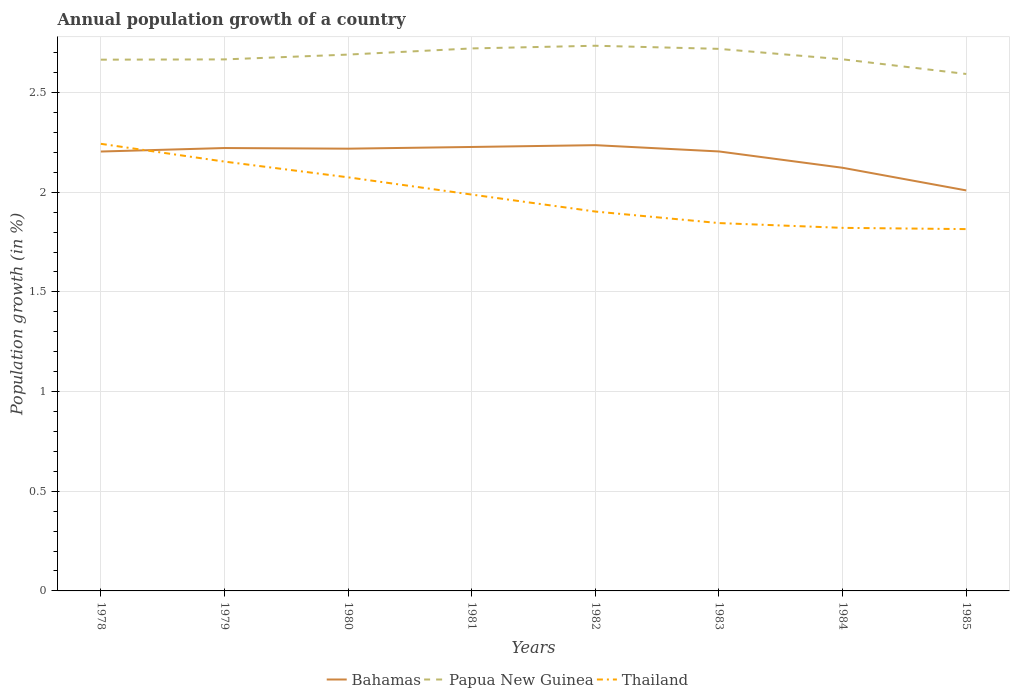How many different coloured lines are there?
Your response must be concise. 3. Does the line corresponding to Bahamas intersect with the line corresponding to Papua New Guinea?
Your response must be concise. No. Is the number of lines equal to the number of legend labels?
Give a very brief answer. Yes. Across all years, what is the maximum annual population growth in Papua New Guinea?
Offer a terse response. 2.59. What is the total annual population growth in Papua New Guinea in the graph?
Your answer should be very brief. -0.06. What is the difference between the highest and the second highest annual population growth in Papua New Guinea?
Provide a succinct answer. 0.14. Is the annual population growth in Papua New Guinea strictly greater than the annual population growth in Bahamas over the years?
Make the answer very short. No. How many lines are there?
Provide a short and direct response. 3. What is the difference between two consecutive major ticks on the Y-axis?
Ensure brevity in your answer.  0.5. Are the values on the major ticks of Y-axis written in scientific E-notation?
Offer a very short reply. No. Where does the legend appear in the graph?
Give a very brief answer. Bottom center. How many legend labels are there?
Give a very brief answer. 3. What is the title of the graph?
Make the answer very short. Annual population growth of a country. What is the label or title of the Y-axis?
Provide a short and direct response. Population growth (in %). What is the Population growth (in %) in Bahamas in 1978?
Ensure brevity in your answer.  2.2. What is the Population growth (in %) of Papua New Guinea in 1978?
Your answer should be very brief. 2.66. What is the Population growth (in %) of Thailand in 1978?
Ensure brevity in your answer.  2.24. What is the Population growth (in %) of Bahamas in 1979?
Give a very brief answer. 2.22. What is the Population growth (in %) in Papua New Guinea in 1979?
Give a very brief answer. 2.67. What is the Population growth (in %) of Thailand in 1979?
Your answer should be very brief. 2.15. What is the Population growth (in %) in Bahamas in 1980?
Make the answer very short. 2.22. What is the Population growth (in %) of Papua New Guinea in 1980?
Offer a terse response. 2.69. What is the Population growth (in %) of Thailand in 1980?
Your response must be concise. 2.07. What is the Population growth (in %) of Bahamas in 1981?
Keep it short and to the point. 2.23. What is the Population growth (in %) in Papua New Guinea in 1981?
Your response must be concise. 2.72. What is the Population growth (in %) of Thailand in 1981?
Keep it short and to the point. 1.99. What is the Population growth (in %) in Bahamas in 1982?
Offer a terse response. 2.24. What is the Population growth (in %) in Papua New Guinea in 1982?
Provide a succinct answer. 2.73. What is the Population growth (in %) of Thailand in 1982?
Ensure brevity in your answer.  1.9. What is the Population growth (in %) of Bahamas in 1983?
Your response must be concise. 2.2. What is the Population growth (in %) of Papua New Guinea in 1983?
Give a very brief answer. 2.72. What is the Population growth (in %) of Thailand in 1983?
Offer a very short reply. 1.85. What is the Population growth (in %) in Bahamas in 1984?
Offer a very short reply. 2.12. What is the Population growth (in %) in Papua New Guinea in 1984?
Provide a succinct answer. 2.67. What is the Population growth (in %) of Thailand in 1984?
Your answer should be very brief. 1.82. What is the Population growth (in %) of Bahamas in 1985?
Offer a very short reply. 2.01. What is the Population growth (in %) of Papua New Guinea in 1985?
Make the answer very short. 2.59. What is the Population growth (in %) in Thailand in 1985?
Provide a succinct answer. 1.81. Across all years, what is the maximum Population growth (in %) of Bahamas?
Offer a terse response. 2.24. Across all years, what is the maximum Population growth (in %) in Papua New Guinea?
Keep it short and to the point. 2.73. Across all years, what is the maximum Population growth (in %) of Thailand?
Provide a succinct answer. 2.24. Across all years, what is the minimum Population growth (in %) of Bahamas?
Make the answer very short. 2.01. Across all years, what is the minimum Population growth (in %) of Papua New Guinea?
Offer a very short reply. 2.59. Across all years, what is the minimum Population growth (in %) of Thailand?
Offer a terse response. 1.81. What is the total Population growth (in %) in Bahamas in the graph?
Make the answer very short. 17.44. What is the total Population growth (in %) of Papua New Guinea in the graph?
Offer a terse response. 21.46. What is the total Population growth (in %) of Thailand in the graph?
Your response must be concise. 15.84. What is the difference between the Population growth (in %) of Bahamas in 1978 and that in 1979?
Ensure brevity in your answer.  -0.02. What is the difference between the Population growth (in %) of Papua New Guinea in 1978 and that in 1979?
Your answer should be compact. -0. What is the difference between the Population growth (in %) in Thailand in 1978 and that in 1979?
Your response must be concise. 0.09. What is the difference between the Population growth (in %) in Bahamas in 1978 and that in 1980?
Provide a succinct answer. -0.01. What is the difference between the Population growth (in %) in Papua New Guinea in 1978 and that in 1980?
Ensure brevity in your answer.  -0.03. What is the difference between the Population growth (in %) of Thailand in 1978 and that in 1980?
Your response must be concise. 0.17. What is the difference between the Population growth (in %) in Bahamas in 1978 and that in 1981?
Provide a short and direct response. -0.02. What is the difference between the Population growth (in %) in Papua New Guinea in 1978 and that in 1981?
Your answer should be very brief. -0.06. What is the difference between the Population growth (in %) in Thailand in 1978 and that in 1981?
Make the answer very short. 0.25. What is the difference between the Population growth (in %) in Bahamas in 1978 and that in 1982?
Offer a very short reply. -0.03. What is the difference between the Population growth (in %) in Papua New Guinea in 1978 and that in 1982?
Offer a terse response. -0.07. What is the difference between the Population growth (in %) in Thailand in 1978 and that in 1982?
Offer a terse response. 0.34. What is the difference between the Population growth (in %) in Bahamas in 1978 and that in 1983?
Provide a succinct answer. -0. What is the difference between the Population growth (in %) of Papua New Guinea in 1978 and that in 1983?
Your answer should be very brief. -0.05. What is the difference between the Population growth (in %) in Thailand in 1978 and that in 1983?
Your answer should be compact. 0.4. What is the difference between the Population growth (in %) in Bahamas in 1978 and that in 1984?
Your answer should be very brief. 0.08. What is the difference between the Population growth (in %) of Papua New Guinea in 1978 and that in 1984?
Provide a succinct answer. -0. What is the difference between the Population growth (in %) of Thailand in 1978 and that in 1984?
Your answer should be very brief. 0.42. What is the difference between the Population growth (in %) in Bahamas in 1978 and that in 1985?
Your answer should be very brief. 0.2. What is the difference between the Population growth (in %) in Papua New Guinea in 1978 and that in 1985?
Offer a very short reply. 0.07. What is the difference between the Population growth (in %) in Thailand in 1978 and that in 1985?
Provide a succinct answer. 0.43. What is the difference between the Population growth (in %) in Bahamas in 1979 and that in 1980?
Give a very brief answer. 0. What is the difference between the Population growth (in %) in Papua New Guinea in 1979 and that in 1980?
Your answer should be compact. -0.02. What is the difference between the Population growth (in %) of Thailand in 1979 and that in 1980?
Your answer should be compact. 0.08. What is the difference between the Population growth (in %) in Bahamas in 1979 and that in 1981?
Offer a very short reply. -0.01. What is the difference between the Population growth (in %) of Papua New Guinea in 1979 and that in 1981?
Your response must be concise. -0.06. What is the difference between the Population growth (in %) in Thailand in 1979 and that in 1981?
Keep it short and to the point. 0.17. What is the difference between the Population growth (in %) in Bahamas in 1979 and that in 1982?
Offer a terse response. -0.01. What is the difference between the Population growth (in %) in Papua New Guinea in 1979 and that in 1982?
Make the answer very short. -0.07. What is the difference between the Population growth (in %) in Thailand in 1979 and that in 1982?
Make the answer very short. 0.25. What is the difference between the Population growth (in %) of Bahamas in 1979 and that in 1983?
Give a very brief answer. 0.02. What is the difference between the Population growth (in %) in Papua New Guinea in 1979 and that in 1983?
Your answer should be very brief. -0.05. What is the difference between the Population growth (in %) of Thailand in 1979 and that in 1983?
Offer a very short reply. 0.31. What is the difference between the Population growth (in %) in Bahamas in 1979 and that in 1984?
Keep it short and to the point. 0.1. What is the difference between the Population growth (in %) in Papua New Guinea in 1979 and that in 1984?
Your answer should be compact. -0. What is the difference between the Population growth (in %) of Thailand in 1979 and that in 1984?
Your response must be concise. 0.33. What is the difference between the Population growth (in %) in Bahamas in 1979 and that in 1985?
Your response must be concise. 0.21. What is the difference between the Population growth (in %) of Papua New Guinea in 1979 and that in 1985?
Offer a very short reply. 0.07. What is the difference between the Population growth (in %) of Thailand in 1979 and that in 1985?
Ensure brevity in your answer.  0.34. What is the difference between the Population growth (in %) of Bahamas in 1980 and that in 1981?
Offer a terse response. -0.01. What is the difference between the Population growth (in %) of Papua New Guinea in 1980 and that in 1981?
Provide a succinct answer. -0.03. What is the difference between the Population growth (in %) in Thailand in 1980 and that in 1981?
Make the answer very short. 0.09. What is the difference between the Population growth (in %) of Bahamas in 1980 and that in 1982?
Offer a terse response. -0.02. What is the difference between the Population growth (in %) of Papua New Guinea in 1980 and that in 1982?
Offer a terse response. -0.04. What is the difference between the Population growth (in %) of Thailand in 1980 and that in 1982?
Ensure brevity in your answer.  0.17. What is the difference between the Population growth (in %) of Bahamas in 1980 and that in 1983?
Make the answer very short. 0.01. What is the difference between the Population growth (in %) of Papua New Guinea in 1980 and that in 1983?
Provide a succinct answer. -0.03. What is the difference between the Population growth (in %) in Thailand in 1980 and that in 1983?
Keep it short and to the point. 0.23. What is the difference between the Population growth (in %) of Bahamas in 1980 and that in 1984?
Give a very brief answer. 0.1. What is the difference between the Population growth (in %) of Papua New Guinea in 1980 and that in 1984?
Your answer should be compact. 0.02. What is the difference between the Population growth (in %) in Thailand in 1980 and that in 1984?
Provide a short and direct response. 0.25. What is the difference between the Population growth (in %) of Bahamas in 1980 and that in 1985?
Your answer should be compact. 0.21. What is the difference between the Population growth (in %) of Papua New Guinea in 1980 and that in 1985?
Your answer should be compact. 0.1. What is the difference between the Population growth (in %) in Thailand in 1980 and that in 1985?
Your answer should be compact. 0.26. What is the difference between the Population growth (in %) in Bahamas in 1981 and that in 1982?
Offer a very short reply. -0.01. What is the difference between the Population growth (in %) in Papua New Guinea in 1981 and that in 1982?
Give a very brief answer. -0.01. What is the difference between the Population growth (in %) of Thailand in 1981 and that in 1982?
Make the answer very short. 0.09. What is the difference between the Population growth (in %) of Bahamas in 1981 and that in 1983?
Your answer should be very brief. 0.02. What is the difference between the Population growth (in %) in Papua New Guinea in 1981 and that in 1983?
Your answer should be very brief. 0. What is the difference between the Population growth (in %) in Thailand in 1981 and that in 1983?
Offer a very short reply. 0.14. What is the difference between the Population growth (in %) in Bahamas in 1981 and that in 1984?
Keep it short and to the point. 0.1. What is the difference between the Population growth (in %) in Papua New Guinea in 1981 and that in 1984?
Offer a very short reply. 0.05. What is the difference between the Population growth (in %) in Thailand in 1981 and that in 1984?
Your answer should be compact. 0.17. What is the difference between the Population growth (in %) in Bahamas in 1981 and that in 1985?
Keep it short and to the point. 0.22. What is the difference between the Population growth (in %) in Papua New Guinea in 1981 and that in 1985?
Give a very brief answer. 0.13. What is the difference between the Population growth (in %) of Thailand in 1981 and that in 1985?
Ensure brevity in your answer.  0.17. What is the difference between the Population growth (in %) of Bahamas in 1982 and that in 1983?
Give a very brief answer. 0.03. What is the difference between the Population growth (in %) in Papua New Guinea in 1982 and that in 1983?
Ensure brevity in your answer.  0.02. What is the difference between the Population growth (in %) of Thailand in 1982 and that in 1983?
Offer a very short reply. 0.06. What is the difference between the Population growth (in %) in Bahamas in 1982 and that in 1984?
Give a very brief answer. 0.11. What is the difference between the Population growth (in %) of Papua New Guinea in 1982 and that in 1984?
Keep it short and to the point. 0.07. What is the difference between the Population growth (in %) in Thailand in 1982 and that in 1984?
Give a very brief answer. 0.08. What is the difference between the Population growth (in %) of Bahamas in 1982 and that in 1985?
Provide a succinct answer. 0.23. What is the difference between the Population growth (in %) of Papua New Guinea in 1982 and that in 1985?
Offer a very short reply. 0.14. What is the difference between the Population growth (in %) of Thailand in 1982 and that in 1985?
Ensure brevity in your answer.  0.09. What is the difference between the Population growth (in %) in Bahamas in 1983 and that in 1984?
Provide a succinct answer. 0.08. What is the difference between the Population growth (in %) of Papua New Guinea in 1983 and that in 1984?
Give a very brief answer. 0.05. What is the difference between the Population growth (in %) in Thailand in 1983 and that in 1984?
Give a very brief answer. 0.02. What is the difference between the Population growth (in %) in Bahamas in 1983 and that in 1985?
Keep it short and to the point. 0.2. What is the difference between the Population growth (in %) in Papua New Guinea in 1983 and that in 1985?
Provide a short and direct response. 0.13. What is the difference between the Population growth (in %) of Thailand in 1983 and that in 1985?
Offer a very short reply. 0.03. What is the difference between the Population growth (in %) of Bahamas in 1984 and that in 1985?
Your answer should be very brief. 0.11. What is the difference between the Population growth (in %) in Papua New Guinea in 1984 and that in 1985?
Ensure brevity in your answer.  0.07. What is the difference between the Population growth (in %) in Thailand in 1984 and that in 1985?
Your response must be concise. 0.01. What is the difference between the Population growth (in %) in Bahamas in 1978 and the Population growth (in %) in Papua New Guinea in 1979?
Offer a very short reply. -0.46. What is the difference between the Population growth (in %) in Bahamas in 1978 and the Population growth (in %) in Thailand in 1979?
Your answer should be very brief. 0.05. What is the difference between the Population growth (in %) of Papua New Guinea in 1978 and the Population growth (in %) of Thailand in 1979?
Keep it short and to the point. 0.51. What is the difference between the Population growth (in %) of Bahamas in 1978 and the Population growth (in %) of Papua New Guinea in 1980?
Offer a terse response. -0.49. What is the difference between the Population growth (in %) in Bahamas in 1978 and the Population growth (in %) in Thailand in 1980?
Your answer should be compact. 0.13. What is the difference between the Population growth (in %) of Papua New Guinea in 1978 and the Population growth (in %) of Thailand in 1980?
Your answer should be compact. 0.59. What is the difference between the Population growth (in %) in Bahamas in 1978 and the Population growth (in %) in Papua New Guinea in 1981?
Provide a short and direct response. -0.52. What is the difference between the Population growth (in %) of Bahamas in 1978 and the Population growth (in %) of Thailand in 1981?
Make the answer very short. 0.22. What is the difference between the Population growth (in %) in Papua New Guinea in 1978 and the Population growth (in %) in Thailand in 1981?
Offer a very short reply. 0.68. What is the difference between the Population growth (in %) of Bahamas in 1978 and the Population growth (in %) of Papua New Guinea in 1982?
Provide a succinct answer. -0.53. What is the difference between the Population growth (in %) in Bahamas in 1978 and the Population growth (in %) in Thailand in 1982?
Your answer should be very brief. 0.3. What is the difference between the Population growth (in %) of Papua New Guinea in 1978 and the Population growth (in %) of Thailand in 1982?
Your answer should be compact. 0.76. What is the difference between the Population growth (in %) in Bahamas in 1978 and the Population growth (in %) in Papua New Guinea in 1983?
Offer a very short reply. -0.52. What is the difference between the Population growth (in %) of Bahamas in 1978 and the Population growth (in %) of Thailand in 1983?
Your answer should be compact. 0.36. What is the difference between the Population growth (in %) of Papua New Guinea in 1978 and the Population growth (in %) of Thailand in 1983?
Your response must be concise. 0.82. What is the difference between the Population growth (in %) in Bahamas in 1978 and the Population growth (in %) in Papua New Guinea in 1984?
Your response must be concise. -0.46. What is the difference between the Population growth (in %) of Bahamas in 1978 and the Population growth (in %) of Thailand in 1984?
Your answer should be very brief. 0.38. What is the difference between the Population growth (in %) of Papua New Guinea in 1978 and the Population growth (in %) of Thailand in 1984?
Ensure brevity in your answer.  0.84. What is the difference between the Population growth (in %) of Bahamas in 1978 and the Population growth (in %) of Papua New Guinea in 1985?
Your response must be concise. -0.39. What is the difference between the Population growth (in %) in Bahamas in 1978 and the Population growth (in %) in Thailand in 1985?
Offer a terse response. 0.39. What is the difference between the Population growth (in %) in Papua New Guinea in 1978 and the Population growth (in %) in Thailand in 1985?
Make the answer very short. 0.85. What is the difference between the Population growth (in %) in Bahamas in 1979 and the Population growth (in %) in Papua New Guinea in 1980?
Offer a terse response. -0.47. What is the difference between the Population growth (in %) in Bahamas in 1979 and the Population growth (in %) in Thailand in 1980?
Keep it short and to the point. 0.15. What is the difference between the Population growth (in %) in Papua New Guinea in 1979 and the Population growth (in %) in Thailand in 1980?
Offer a terse response. 0.59. What is the difference between the Population growth (in %) in Bahamas in 1979 and the Population growth (in %) in Papua New Guinea in 1981?
Give a very brief answer. -0.5. What is the difference between the Population growth (in %) in Bahamas in 1979 and the Population growth (in %) in Thailand in 1981?
Provide a succinct answer. 0.23. What is the difference between the Population growth (in %) in Papua New Guinea in 1979 and the Population growth (in %) in Thailand in 1981?
Make the answer very short. 0.68. What is the difference between the Population growth (in %) in Bahamas in 1979 and the Population growth (in %) in Papua New Guinea in 1982?
Ensure brevity in your answer.  -0.51. What is the difference between the Population growth (in %) of Bahamas in 1979 and the Population growth (in %) of Thailand in 1982?
Provide a succinct answer. 0.32. What is the difference between the Population growth (in %) of Papua New Guinea in 1979 and the Population growth (in %) of Thailand in 1982?
Give a very brief answer. 0.76. What is the difference between the Population growth (in %) of Bahamas in 1979 and the Population growth (in %) of Papua New Guinea in 1983?
Provide a short and direct response. -0.5. What is the difference between the Population growth (in %) in Bahamas in 1979 and the Population growth (in %) in Thailand in 1983?
Your answer should be very brief. 0.38. What is the difference between the Population growth (in %) in Papua New Guinea in 1979 and the Population growth (in %) in Thailand in 1983?
Your response must be concise. 0.82. What is the difference between the Population growth (in %) of Bahamas in 1979 and the Population growth (in %) of Papua New Guinea in 1984?
Make the answer very short. -0.45. What is the difference between the Population growth (in %) of Bahamas in 1979 and the Population growth (in %) of Thailand in 1984?
Ensure brevity in your answer.  0.4. What is the difference between the Population growth (in %) of Papua New Guinea in 1979 and the Population growth (in %) of Thailand in 1984?
Make the answer very short. 0.85. What is the difference between the Population growth (in %) of Bahamas in 1979 and the Population growth (in %) of Papua New Guinea in 1985?
Your answer should be very brief. -0.37. What is the difference between the Population growth (in %) of Bahamas in 1979 and the Population growth (in %) of Thailand in 1985?
Your answer should be very brief. 0.41. What is the difference between the Population growth (in %) in Papua New Guinea in 1979 and the Population growth (in %) in Thailand in 1985?
Make the answer very short. 0.85. What is the difference between the Population growth (in %) of Bahamas in 1980 and the Population growth (in %) of Papua New Guinea in 1981?
Offer a terse response. -0.5. What is the difference between the Population growth (in %) of Bahamas in 1980 and the Population growth (in %) of Thailand in 1981?
Give a very brief answer. 0.23. What is the difference between the Population growth (in %) in Papua New Guinea in 1980 and the Population growth (in %) in Thailand in 1981?
Make the answer very short. 0.7. What is the difference between the Population growth (in %) in Bahamas in 1980 and the Population growth (in %) in Papua New Guinea in 1982?
Ensure brevity in your answer.  -0.52. What is the difference between the Population growth (in %) of Bahamas in 1980 and the Population growth (in %) of Thailand in 1982?
Give a very brief answer. 0.32. What is the difference between the Population growth (in %) of Papua New Guinea in 1980 and the Population growth (in %) of Thailand in 1982?
Give a very brief answer. 0.79. What is the difference between the Population growth (in %) in Bahamas in 1980 and the Population growth (in %) in Papua New Guinea in 1983?
Offer a terse response. -0.5. What is the difference between the Population growth (in %) of Bahamas in 1980 and the Population growth (in %) of Thailand in 1983?
Provide a short and direct response. 0.37. What is the difference between the Population growth (in %) of Papua New Guinea in 1980 and the Population growth (in %) of Thailand in 1983?
Your response must be concise. 0.85. What is the difference between the Population growth (in %) in Bahamas in 1980 and the Population growth (in %) in Papua New Guinea in 1984?
Your answer should be compact. -0.45. What is the difference between the Population growth (in %) in Bahamas in 1980 and the Population growth (in %) in Thailand in 1984?
Your answer should be compact. 0.4. What is the difference between the Population growth (in %) in Papua New Guinea in 1980 and the Population growth (in %) in Thailand in 1984?
Keep it short and to the point. 0.87. What is the difference between the Population growth (in %) in Bahamas in 1980 and the Population growth (in %) in Papua New Guinea in 1985?
Provide a short and direct response. -0.37. What is the difference between the Population growth (in %) in Bahamas in 1980 and the Population growth (in %) in Thailand in 1985?
Your answer should be very brief. 0.4. What is the difference between the Population growth (in %) of Papua New Guinea in 1980 and the Population growth (in %) of Thailand in 1985?
Offer a terse response. 0.88. What is the difference between the Population growth (in %) in Bahamas in 1981 and the Population growth (in %) in Papua New Guinea in 1982?
Your answer should be compact. -0.51. What is the difference between the Population growth (in %) in Bahamas in 1981 and the Population growth (in %) in Thailand in 1982?
Your response must be concise. 0.32. What is the difference between the Population growth (in %) of Papua New Guinea in 1981 and the Population growth (in %) of Thailand in 1982?
Offer a terse response. 0.82. What is the difference between the Population growth (in %) in Bahamas in 1981 and the Population growth (in %) in Papua New Guinea in 1983?
Ensure brevity in your answer.  -0.49. What is the difference between the Population growth (in %) of Bahamas in 1981 and the Population growth (in %) of Thailand in 1983?
Your answer should be very brief. 0.38. What is the difference between the Population growth (in %) in Papua New Guinea in 1981 and the Population growth (in %) in Thailand in 1983?
Offer a very short reply. 0.88. What is the difference between the Population growth (in %) of Bahamas in 1981 and the Population growth (in %) of Papua New Guinea in 1984?
Ensure brevity in your answer.  -0.44. What is the difference between the Population growth (in %) of Bahamas in 1981 and the Population growth (in %) of Thailand in 1984?
Offer a terse response. 0.41. What is the difference between the Population growth (in %) in Papua New Guinea in 1981 and the Population growth (in %) in Thailand in 1984?
Your response must be concise. 0.9. What is the difference between the Population growth (in %) of Bahamas in 1981 and the Population growth (in %) of Papua New Guinea in 1985?
Your answer should be very brief. -0.37. What is the difference between the Population growth (in %) in Bahamas in 1981 and the Population growth (in %) in Thailand in 1985?
Provide a short and direct response. 0.41. What is the difference between the Population growth (in %) in Papua New Guinea in 1981 and the Population growth (in %) in Thailand in 1985?
Provide a succinct answer. 0.91. What is the difference between the Population growth (in %) of Bahamas in 1982 and the Population growth (in %) of Papua New Guinea in 1983?
Offer a very short reply. -0.48. What is the difference between the Population growth (in %) of Bahamas in 1982 and the Population growth (in %) of Thailand in 1983?
Offer a terse response. 0.39. What is the difference between the Population growth (in %) of Papua New Guinea in 1982 and the Population growth (in %) of Thailand in 1983?
Your answer should be very brief. 0.89. What is the difference between the Population growth (in %) in Bahamas in 1982 and the Population growth (in %) in Papua New Guinea in 1984?
Offer a terse response. -0.43. What is the difference between the Population growth (in %) of Bahamas in 1982 and the Population growth (in %) of Thailand in 1984?
Give a very brief answer. 0.41. What is the difference between the Population growth (in %) of Papua New Guinea in 1982 and the Population growth (in %) of Thailand in 1984?
Provide a succinct answer. 0.91. What is the difference between the Population growth (in %) in Bahamas in 1982 and the Population growth (in %) in Papua New Guinea in 1985?
Offer a very short reply. -0.36. What is the difference between the Population growth (in %) in Bahamas in 1982 and the Population growth (in %) in Thailand in 1985?
Your answer should be compact. 0.42. What is the difference between the Population growth (in %) of Papua New Guinea in 1982 and the Population growth (in %) of Thailand in 1985?
Offer a terse response. 0.92. What is the difference between the Population growth (in %) in Bahamas in 1983 and the Population growth (in %) in Papua New Guinea in 1984?
Provide a short and direct response. -0.46. What is the difference between the Population growth (in %) of Bahamas in 1983 and the Population growth (in %) of Thailand in 1984?
Ensure brevity in your answer.  0.38. What is the difference between the Population growth (in %) of Papua New Guinea in 1983 and the Population growth (in %) of Thailand in 1984?
Make the answer very short. 0.9. What is the difference between the Population growth (in %) in Bahamas in 1983 and the Population growth (in %) in Papua New Guinea in 1985?
Make the answer very short. -0.39. What is the difference between the Population growth (in %) of Bahamas in 1983 and the Population growth (in %) of Thailand in 1985?
Keep it short and to the point. 0.39. What is the difference between the Population growth (in %) of Papua New Guinea in 1983 and the Population growth (in %) of Thailand in 1985?
Make the answer very short. 0.9. What is the difference between the Population growth (in %) of Bahamas in 1984 and the Population growth (in %) of Papua New Guinea in 1985?
Make the answer very short. -0.47. What is the difference between the Population growth (in %) in Bahamas in 1984 and the Population growth (in %) in Thailand in 1985?
Keep it short and to the point. 0.31. What is the difference between the Population growth (in %) of Papua New Guinea in 1984 and the Population growth (in %) of Thailand in 1985?
Provide a short and direct response. 0.85. What is the average Population growth (in %) of Bahamas per year?
Your answer should be compact. 2.18. What is the average Population growth (in %) of Papua New Guinea per year?
Your answer should be compact. 2.68. What is the average Population growth (in %) in Thailand per year?
Offer a very short reply. 1.98. In the year 1978, what is the difference between the Population growth (in %) of Bahamas and Population growth (in %) of Papua New Guinea?
Your answer should be compact. -0.46. In the year 1978, what is the difference between the Population growth (in %) in Bahamas and Population growth (in %) in Thailand?
Provide a short and direct response. -0.04. In the year 1978, what is the difference between the Population growth (in %) of Papua New Guinea and Population growth (in %) of Thailand?
Your response must be concise. 0.42. In the year 1979, what is the difference between the Population growth (in %) in Bahamas and Population growth (in %) in Papua New Guinea?
Offer a terse response. -0.44. In the year 1979, what is the difference between the Population growth (in %) of Bahamas and Population growth (in %) of Thailand?
Your answer should be compact. 0.07. In the year 1979, what is the difference between the Population growth (in %) in Papua New Guinea and Population growth (in %) in Thailand?
Your response must be concise. 0.51. In the year 1980, what is the difference between the Population growth (in %) in Bahamas and Population growth (in %) in Papua New Guinea?
Offer a very short reply. -0.47. In the year 1980, what is the difference between the Population growth (in %) in Bahamas and Population growth (in %) in Thailand?
Provide a succinct answer. 0.14. In the year 1980, what is the difference between the Population growth (in %) in Papua New Guinea and Population growth (in %) in Thailand?
Offer a terse response. 0.62. In the year 1981, what is the difference between the Population growth (in %) of Bahamas and Population growth (in %) of Papua New Guinea?
Your response must be concise. -0.49. In the year 1981, what is the difference between the Population growth (in %) in Bahamas and Population growth (in %) in Thailand?
Ensure brevity in your answer.  0.24. In the year 1981, what is the difference between the Population growth (in %) of Papua New Guinea and Population growth (in %) of Thailand?
Make the answer very short. 0.73. In the year 1982, what is the difference between the Population growth (in %) of Bahamas and Population growth (in %) of Papua New Guinea?
Ensure brevity in your answer.  -0.5. In the year 1982, what is the difference between the Population growth (in %) of Bahamas and Population growth (in %) of Thailand?
Provide a short and direct response. 0.33. In the year 1982, what is the difference between the Population growth (in %) of Papua New Guinea and Population growth (in %) of Thailand?
Give a very brief answer. 0.83. In the year 1983, what is the difference between the Population growth (in %) of Bahamas and Population growth (in %) of Papua New Guinea?
Your answer should be compact. -0.51. In the year 1983, what is the difference between the Population growth (in %) of Bahamas and Population growth (in %) of Thailand?
Give a very brief answer. 0.36. In the year 1983, what is the difference between the Population growth (in %) in Papua New Guinea and Population growth (in %) in Thailand?
Make the answer very short. 0.87. In the year 1984, what is the difference between the Population growth (in %) of Bahamas and Population growth (in %) of Papua New Guinea?
Provide a short and direct response. -0.54. In the year 1984, what is the difference between the Population growth (in %) of Bahamas and Population growth (in %) of Thailand?
Keep it short and to the point. 0.3. In the year 1984, what is the difference between the Population growth (in %) in Papua New Guinea and Population growth (in %) in Thailand?
Offer a very short reply. 0.85. In the year 1985, what is the difference between the Population growth (in %) of Bahamas and Population growth (in %) of Papua New Guinea?
Provide a succinct answer. -0.58. In the year 1985, what is the difference between the Population growth (in %) in Bahamas and Population growth (in %) in Thailand?
Offer a terse response. 0.19. In the year 1985, what is the difference between the Population growth (in %) of Papua New Guinea and Population growth (in %) of Thailand?
Provide a succinct answer. 0.78. What is the ratio of the Population growth (in %) in Thailand in 1978 to that in 1979?
Keep it short and to the point. 1.04. What is the ratio of the Population growth (in %) in Papua New Guinea in 1978 to that in 1980?
Keep it short and to the point. 0.99. What is the ratio of the Population growth (in %) in Thailand in 1978 to that in 1980?
Offer a very short reply. 1.08. What is the ratio of the Population growth (in %) in Bahamas in 1978 to that in 1981?
Your response must be concise. 0.99. What is the ratio of the Population growth (in %) in Papua New Guinea in 1978 to that in 1981?
Make the answer very short. 0.98. What is the ratio of the Population growth (in %) of Thailand in 1978 to that in 1981?
Ensure brevity in your answer.  1.13. What is the ratio of the Population growth (in %) of Bahamas in 1978 to that in 1982?
Offer a very short reply. 0.99. What is the ratio of the Population growth (in %) in Papua New Guinea in 1978 to that in 1982?
Give a very brief answer. 0.97. What is the ratio of the Population growth (in %) of Thailand in 1978 to that in 1982?
Give a very brief answer. 1.18. What is the ratio of the Population growth (in %) of Papua New Guinea in 1978 to that in 1983?
Offer a very short reply. 0.98. What is the ratio of the Population growth (in %) of Thailand in 1978 to that in 1983?
Your answer should be very brief. 1.22. What is the ratio of the Population growth (in %) in Bahamas in 1978 to that in 1984?
Provide a short and direct response. 1.04. What is the ratio of the Population growth (in %) in Papua New Guinea in 1978 to that in 1984?
Keep it short and to the point. 1. What is the ratio of the Population growth (in %) in Thailand in 1978 to that in 1984?
Offer a very short reply. 1.23. What is the ratio of the Population growth (in %) in Bahamas in 1978 to that in 1985?
Your response must be concise. 1.1. What is the ratio of the Population growth (in %) in Papua New Guinea in 1978 to that in 1985?
Your answer should be compact. 1.03. What is the ratio of the Population growth (in %) of Thailand in 1978 to that in 1985?
Make the answer very short. 1.24. What is the ratio of the Population growth (in %) in Bahamas in 1979 to that in 1980?
Give a very brief answer. 1. What is the ratio of the Population growth (in %) of Thailand in 1979 to that in 1980?
Provide a short and direct response. 1.04. What is the ratio of the Population growth (in %) in Bahamas in 1979 to that in 1981?
Your answer should be very brief. 1. What is the ratio of the Population growth (in %) of Papua New Guinea in 1979 to that in 1981?
Make the answer very short. 0.98. What is the ratio of the Population growth (in %) of Thailand in 1979 to that in 1981?
Provide a succinct answer. 1.08. What is the ratio of the Population growth (in %) of Papua New Guinea in 1979 to that in 1982?
Your answer should be compact. 0.97. What is the ratio of the Population growth (in %) in Thailand in 1979 to that in 1982?
Offer a terse response. 1.13. What is the ratio of the Population growth (in %) of Papua New Guinea in 1979 to that in 1983?
Provide a short and direct response. 0.98. What is the ratio of the Population growth (in %) of Thailand in 1979 to that in 1983?
Offer a very short reply. 1.17. What is the ratio of the Population growth (in %) in Bahamas in 1979 to that in 1984?
Keep it short and to the point. 1.05. What is the ratio of the Population growth (in %) of Papua New Guinea in 1979 to that in 1984?
Your answer should be very brief. 1. What is the ratio of the Population growth (in %) of Thailand in 1979 to that in 1984?
Provide a succinct answer. 1.18. What is the ratio of the Population growth (in %) in Bahamas in 1979 to that in 1985?
Keep it short and to the point. 1.11. What is the ratio of the Population growth (in %) in Papua New Guinea in 1979 to that in 1985?
Offer a very short reply. 1.03. What is the ratio of the Population growth (in %) of Thailand in 1979 to that in 1985?
Keep it short and to the point. 1.19. What is the ratio of the Population growth (in %) in Papua New Guinea in 1980 to that in 1981?
Give a very brief answer. 0.99. What is the ratio of the Population growth (in %) of Thailand in 1980 to that in 1981?
Provide a short and direct response. 1.04. What is the ratio of the Population growth (in %) of Papua New Guinea in 1980 to that in 1982?
Make the answer very short. 0.98. What is the ratio of the Population growth (in %) of Thailand in 1980 to that in 1982?
Give a very brief answer. 1.09. What is the ratio of the Population growth (in %) of Bahamas in 1980 to that in 1983?
Offer a very short reply. 1.01. What is the ratio of the Population growth (in %) in Thailand in 1980 to that in 1983?
Make the answer very short. 1.12. What is the ratio of the Population growth (in %) of Bahamas in 1980 to that in 1984?
Ensure brevity in your answer.  1.05. What is the ratio of the Population growth (in %) in Papua New Guinea in 1980 to that in 1984?
Offer a very short reply. 1.01. What is the ratio of the Population growth (in %) of Thailand in 1980 to that in 1984?
Provide a succinct answer. 1.14. What is the ratio of the Population growth (in %) of Bahamas in 1980 to that in 1985?
Offer a very short reply. 1.1. What is the ratio of the Population growth (in %) in Papua New Guinea in 1980 to that in 1985?
Ensure brevity in your answer.  1.04. What is the ratio of the Population growth (in %) in Thailand in 1980 to that in 1985?
Keep it short and to the point. 1.14. What is the ratio of the Population growth (in %) in Bahamas in 1981 to that in 1982?
Your answer should be very brief. 1. What is the ratio of the Population growth (in %) in Thailand in 1981 to that in 1982?
Keep it short and to the point. 1.04. What is the ratio of the Population growth (in %) in Bahamas in 1981 to that in 1983?
Provide a short and direct response. 1.01. What is the ratio of the Population growth (in %) of Papua New Guinea in 1981 to that in 1983?
Keep it short and to the point. 1. What is the ratio of the Population growth (in %) of Thailand in 1981 to that in 1983?
Keep it short and to the point. 1.08. What is the ratio of the Population growth (in %) in Bahamas in 1981 to that in 1984?
Give a very brief answer. 1.05. What is the ratio of the Population growth (in %) of Papua New Guinea in 1981 to that in 1984?
Provide a short and direct response. 1.02. What is the ratio of the Population growth (in %) in Thailand in 1981 to that in 1984?
Your response must be concise. 1.09. What is the ratio of the Population growth (in %) in Bahamas in 1981 to that in 1985?
Offer a very short reply. 1.11. What is the ratio of the Population growth (in %) of Papua New Guinea in 1981 to that in 1985?
Make the answer very short. 1.05. What is the ratio of the Population growth (in %) of Thailand in 1981 to that in 1985?
Keep it short and to the point. 1.1. What is the ratio of the Population growth (in %) of Bahamas in 1982 to that in 1983?
Your response must be concise. 1.01. What is the ratio of the Population growth (in %) of Thailand in 1982 to that in 1983?
Ensure brevity in your answer.  1.03. What is the ratio of the Population growth (in %) of Bahamas in 1982 to that in 1984?
Make the answer very short. 1.05. What is the ratio of the Population growth (in %) in Papua New Guinea in 1982 to that in 1984?
Your answer should be very brief. 1.03. What is the ratio of the Population growth (in %) of Thailand in 1982 to that in 1984?
Your answer should be compact. 1.04. What is the ratio of the Population growth (in %) in Bahamas in 1982 to that in 1985?
Offer a very short reply. 1.11. What is the ratio of the Population growth (in %) of Papua New Guinea in 1982 to that in 1985?
Your answer should be very brief. 1.05. What is the ratio of the Population growth (in %) of Thailand in 1982 to that in 1985?
Make the answer very short. 1.05. What is the ratio of the Population growth (in %) in Bahamas in 1983 to that in 1984?
Provide a succinct answer. 1.04. What is the ratio of the Population growth (in %) in Papua New Guinea in 1983 to that in 1984?
Provide a succinct answer. 1.02. What is the ratio of the Population growth (in %) of Thailand in 1983 to that in 1984?
Make the answer very short. 1.01. What is the ratio of the Population growth (in %) in Bahamas in 1983 to that in 1985?
Ensure brevity in your answer.  1.1. What is the ratio of the Population growth (in %) in Papua New Guinea in 1983 to that in 1985?
Provide a short and direct response. 1.05. What is the ratio of the Population growth (in %) in Thailand in 1983 to that in 1985?
Give a very brief answer. 1.02. What is the ratio of the Population growth (in %) of Bahamas in 1984 to that in 1985?
Your answer should be compact. 1.06. What is the ratio of the Population growth (in %) of Papua New Guinea in 1984 to that in 1985?
Offer a very short reply. 1.03. What is the difference between the highest and the second highest Population growth (in %) in Bahamas?
Ensure brevity in your answer.  0.01. What is the difference between the highest and the second highest Population growth (in %) in Papua New Guinea?
Make the answer very short. 0.01. What is the difference between the highest and the second highest Population growth (in %) of Thailand?
Make the answer very short. 0.09. What is the difference between the highest and the lowest Population growth (in %) in Bahamas?
Offer a very short reply. 0.23. What is the difference between the highest and the lowest Population growth (in %) of Papua New Guinea?
Provide a succinct answer. 0.14. What is the difference between the highest and the lowest Population growth (in %) of Thailand?
Offer a very short reply. 0.43. 